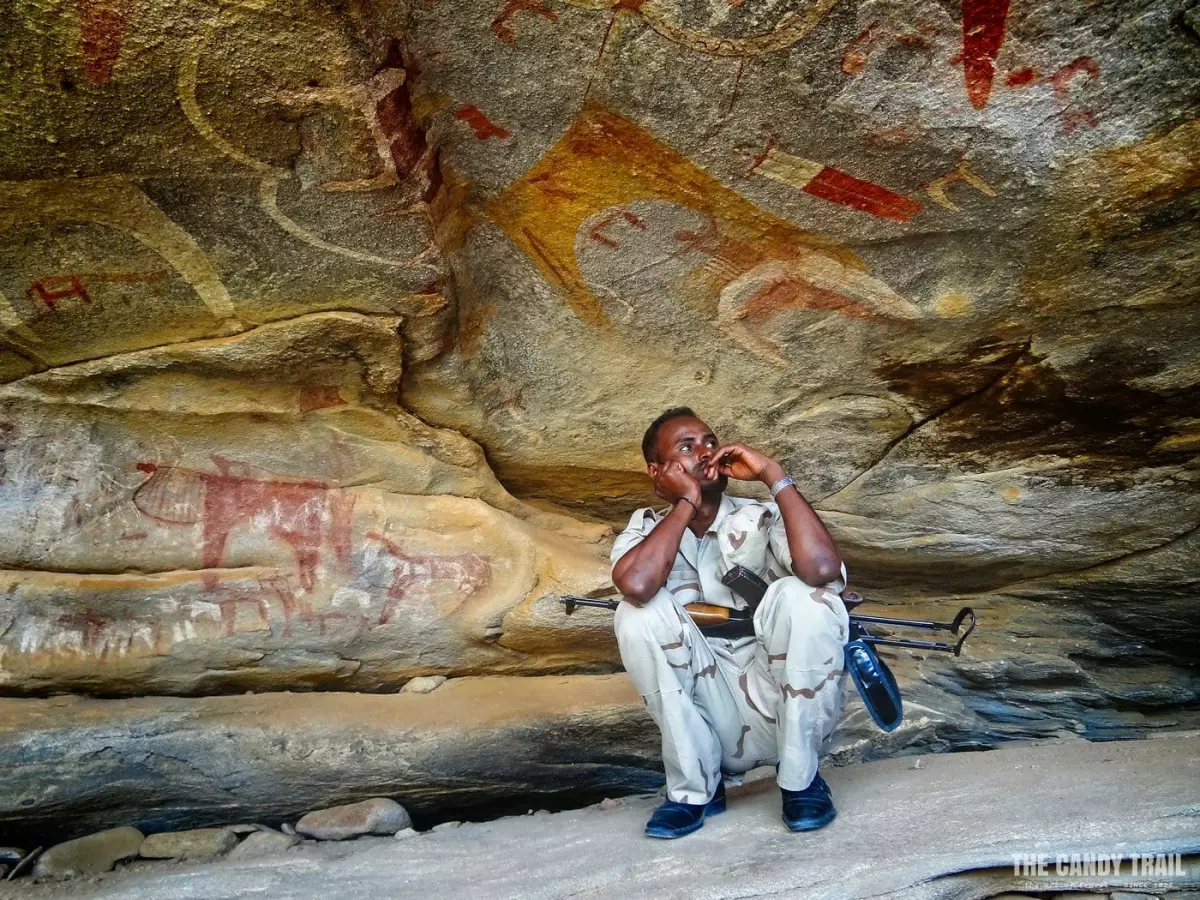What might the man be thinking as he sits here? While it's impossible to know his exact thoughts, the man might be reflecting on the historical depth and cultural richness of the cave. His contemplative pose suggests a deep appreciation or perhaps a personal connection to the heritage depicted around him. His presence alongside ancient artworks might provoke thoughts on the continuity of history and the transient nature of human existence compared to these time-enduring artworks. What does the contrast between his modern clothing and ancient paintings signify? The stark contrast between his modern attire and the ancient cave paintings could symbolize the bridge between past and present. It serves as a visual reminder that while we continue to move forward in time, the legacy and lessons of our ancestors remain with us, captured in art and communal memories. This juxtaposition might evoke a sense of responsibility to preserve and respect our cultural heritage. 